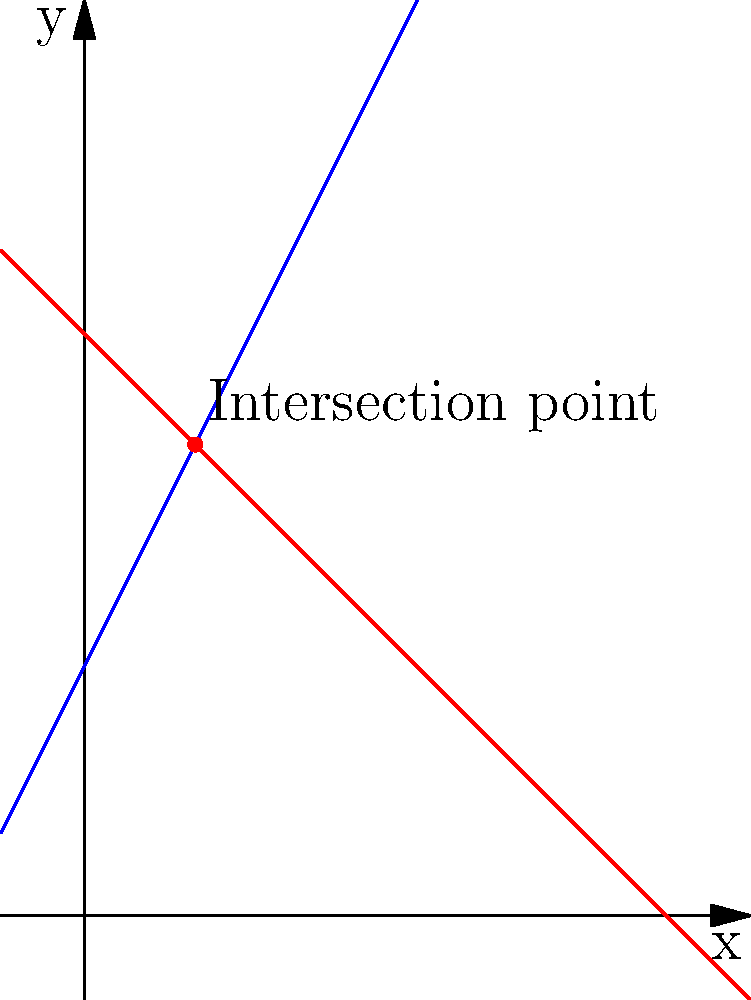During the Battle of Verdun in 1916, Allied and German forces established complex trench systems. Intelligence reports suggest that the Allied trench line can be represented by the equation $y = 2x + 3$, while the German trench line follows $y = -x + 7$. At which point $(x, y)$ do these trench lines intersect, potentially creating a vulnerable position for both sides? To find the intersection point of the two trench lines, we need to solve the system of equations:

1) Allied trench line: $y = 2x + 3$
2) German trench line: $y = -x + 7$

At the intersection point, the $y$ values will be equal. So we can set the right sides of the equations equal to each other:

$2x + 3 = -x + 7$

Now, let's solve for $x$:

$2x + x = 7 - 3$
$3x = 4$
$x = \frac{4}{3}$

To find the $y$ coordinate, we can substitute this $x$ value into either of the original equations. Let's use the Allied trench line equation:

$y = 2(\frac{4}{3}) + 3$
$y = \frac{8}{3} + 3$
$y = \frac{8}{3} + \frac{9}{3}$
$y = \frac{17}{3}$

Therefore, the intersection point is $(\frac{4}{3}, \frac{17}{3})$.

To simplify $\frac{17}{3}$:
$\frac{17}{3} = 5 + \frac{2}{3}$

So, the final intersection point can be expressed as $(\frac{4}{3}, 5\frac{2}{3})$.
Answer: $(\frac{4}{3}, 5\frac{2}{3})$ 